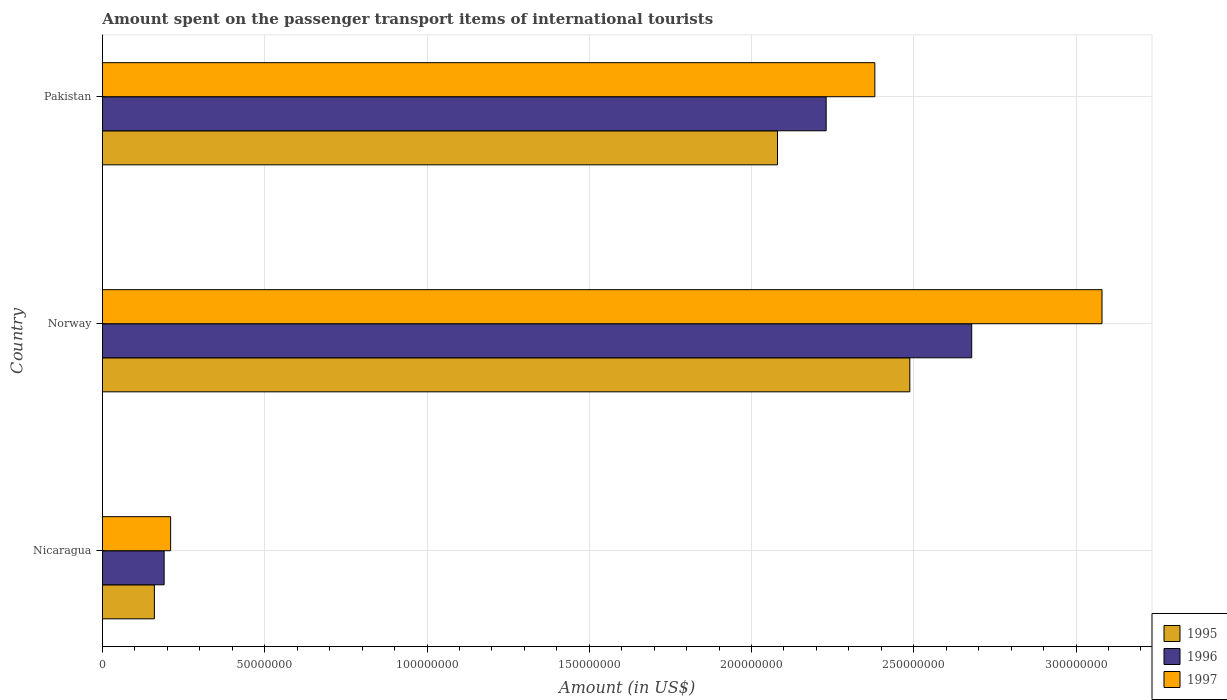What is the amount spent on the passenger transport items of international tourists in 1997 in Norway?
Ensure brevity in your answer.  3.08e+08. Across all countries, what is the maximum amount spent on the passenger transport items of international tourists in 1995?
Give a very brief answer. 2.49e+08. Across all countries, what is the minimum amount spent on the passenger transport items of international tourists in 1995?
Offer a terse response. 1.60e+07. In which country was the amount spent on the passenger transport items of international tourists in 1995 maximum?
Your response must be concise. Norway. In which country was the amount spent on the passenger transport items of international tourists in 1997 minimum?
Make the answer very short. Nicaragua. What is the total amount spent on the passenger transport items of international tourists in 1997 in the graph?
Your response must be concise. 5.67e+08. What is the difference between the amount spent on the passenger transport items of international tourists in 1996 in Nicaragua and that in Norway?
Make the answer very short. -2.49e+08. What is the difference between the amount spent on the passenger transport items of international tourists in 1996 in Pakistan and the amount spent on the passenger transport items of international tourists in 1997 in Norway?
Your answer should be very brief. -8.50e+07. What is the average amount spent on the passenger transport items of international tourists in 1996 per country?
Your answer should be compact. 1.70e+08. What is the difference between the amount spent on the passenger transport items of international tourists in 1996 and amount spent on the passenger transport items of international tourists in 1997 in Pakistan?
Ensure brevity in your answer.  -1.50e+07. What is the ratio of the amount spent on the passenger transport items of international tourists in 1997 in Nicaragua to that in Norway?
Provide a short and direct response. 0.07. What is the difference between the highest and the second highest amount spent on the passenger transport items of international tourists in 1997?
Offer a very short reply. 7.00e+07. What is the difference between the highest and the lowest amount spent on the passenger transport items of international tourists in 1996?
Ensure brevity in your answer.  2.49e+08. In how many countries, is the amount spent on the passenger transport items of international tourists in 1996 greater than the average amount spent on the passenger transport items of international tourists in 1996 taken over all countries?
Offer a terse response. 2. Is the sum of the amount spent on the passenger transport items of international tourists in 1997 in Nicaragua and Norway greater than the maximum amount spent on the passenger transport items of international tourists in 1995 across all countries?
Your response must be concise. Yes. How many bars are there?
Your answer should be compact. 9. What is the difference between two consecutive major ticks on the X-axis?
Offer a very short reply. 5.00e+07. Are the values on the major ticks of X-axis written in scientific E-notation?
Make the answer very short. No. Does the graph contain any zero values?
Offer a terse response. No. What is the title of the graph?
Your answer should be compact. Amount spent on the passenger transport items of international tourists. Does "1983" appear as one of the legend labels in the graph?
Make the answer very short. No. What is the label or title of the Y-axis?
Give a very brief answer. Country. What is the Amount (in US$) of 1995 in Nicaragua?
Offer a terse response. 1.60e+07. What is the Amount (in US$) in 1996 in Nicaragua?
Offer a terse response. 1.90e+07. What is the Amount (in US$) of 1997 in Nicaragua?
Provide a short and direct response. 2.10e+07. What is the Amount (in US$) of 1995 in Norway?
Offer a terse response. 2.49e+08. What is the Amount (in US$) of 1996 in Norway?
Provide a succinct answer. 2.68e+08. What is the Amount (in US$) in 1997 in Norway?
Provide a succinct answer. 3.08e+08. What is the Amount (in US$) of 1995 in Pakistan?
Your answer should be compact. 2.08e+08. What is the Amount (in US$) in 1996 in Pakistan?
Offer a terse response. 2.23e+08. What is the Amount (in US$) of 1997 in Pakistan?
Your answer should be very brief. 2.38e+08. Across all countries, what is the maximum Amount (in US$) in 1995?
Offer a very short reply. 2.49e+08. Across all countries, what is the maximum Amount (in US$) of 1996?
Your answer should be very brief. 2.68e+08. Across all countries, what is the maximum Amount (in US$) in 1997?
Offer a terse response. 3.08e+08. Across all countries, what is the minimum Amount (in US$) of 1995?
Your response must be concise. 1.60e+07. Across all countries, what is the minimum Amount (in US$) of 1996?
Provide a succinct answer. 1.90e+07. Across all countries, what is the minimum Amount (in US$) in 1997?
Keep it short and to the point. 2.10e+07. What is the total Amount (in US$) in 1995 in the graph?
Make the answer very short. 4.73e+08. What is the total Amount (in US$) in 1996 in the graph?
Keep it short and to the point. 5.10e+08. What is the total Amount (in US$) in 1997 in the graph?
Offer a terse response. 5.67e+08. What is the difference between the Amount (in US$) in 1995 in Nicaragua and that in Norway?
Give a very brief answer. -2.33e+08. What is the difference between the Amount (in US$) in 1996 in Nicaragua and that in Norway?
Provide a succinct answer. -2.49e+08. What is the difference between the Amount (in US$) in 1997 in Nicaragua and that in Norway?
Provide a short and direct response. -2.87e+08. What is the difference between the Amount (in US$) in 1995 in Nicaragua and that in Pakistan?
Your answer should be compact. -1.92e+08. What is the difference between the Amount (in US$) of 1996 in Nicaragua and that in Pakistan?
Provide a succinct answer. -2.04e+08. What is the difference between the Amount (in US$) of 1997 in Nicaragua and that in Pakistan?
Your response must be concise. -2.17e+08. What is the difference between the Amount (in US$) in 1995 in Norway and that in Pakistan?
Offer a terse response. 4.08e+07. What is the difference between the Amount (in US$) of 1996 in Norway and that in Pakistan?
Your response must be concise. 4.48e+07. What is the difference between the Amount (in US$) in 1997 in Norway and that in Pakistan?
Your answer should be very brief. 7.00e+07. What is the difference between the Amount (in US$) in 1995 in Nicaragua and the Amount (in US$) in 1996 in Norway?
Keep it short and to the point. -2.52e+08. What is the difference between the Amount (in US$) in 1995 in Nicaragua and the Amount (in US$) in 1997 in Norway?
Your answer should be very brief. -2.92e+08. What is the difference between the Amount (in US$) of 1996 in Nicaragua and the Amount (in US$) of 1997 in Norway?
Provide a succinct answer. -2.89e+08. What is the difference between the Amount (in US$) in 1995 in Nicaragua and the Amount (in US$) in 1996 in Pakistan?
Your answer should be compact. -2.07e+08. What is the difference between the Amount (in US$) in 1995 in Nicaragua and the Amount (in US$) in 1997 in Pakistan?
Make the answer very short. -2.22e+08. What is the difference between the Amount (in US$) of 1996 in Nicaragua and the Amount (in US$) of 1997 in Pakistan?
Keep it short and to the point. -2.19e+08. What is the difference between the Amount (in US$) in 1995 in Norway and the Amount (in US$) in 1996 in Pakistan?
Provide a succinct answer. 2.58e+07. What is the difference between the Amount (in US$) of 1995 in Norway and the Amount (in US$) of 1997 in Pakistan?
Your response must be concise. 1.08e+07. What is the difference between the Amount (in US$) of 1996 in Norway and the Amount (in US$) of 1997 in Pakistan?
Offer a very short reply. 2.98e+07. What is the average Amount (in US$) in 1995 per country?
Ensure brevity in your answer.  1.58e+08. What is the average Amount (in US$) of 1996 per country?
Your answer should be very brief. 1.70e+08. What is the average Amount (in US$) of 1997 per country?
Give a very brief answer. 1.89e+08. What is the difference between the Amount (in US$) of 1995 and Amount (in US$) of 1997 in Nicaragua?
Give a very brief answer. -5.00e+06. What is the difference between the Amount (in US$) of 1996 and Amount (in US$) of 1997 in Nicaragua?
Make the answer very short. -2.00e+06. What is the difference between the Amount (in US$) in 1995 and Amount (in US$) in 1996 in Norway?
Give a very brief answer. -1.91e+07. What is the difference between the Amount (in US$) of 1995 and Amount (in US$) of 1997 in Norway?
Ensure brevity in your answer.  -5.92e+07. What is the difference between the Amount (in US$) in 1996 and Amount (in US$) in 1997 in Norway?
Make the answer very short. -4.02e+07. What is the difference between the Amount (in US$) of 1995 and Amount (in US$) of 1996 in Pakistan?
Ensure brevity in your answer.  -1.50e+07. What is the difference between the Amount (in US$) of 1995 and Amount (in US$) of 1997 in Pakistan?
Your response must be concise. -3.00e+07. What is the difference between the Amount (in US$) of 1996 and Amount (in US$) of 1997 in Pakistan?
Provide a short and direct response. -1.50e+07. What is the ratio of the Amount (in US$) of 1995 in Nicaragua to that in Norway?
Make the answer very short. 0.06. What is the ratio of the Amount (in US$) in 1996 in Nicaragua to that in Norway?
Provide a succinct answer. 0.07. What is the ratio of the Amount (in US$) of 1997 in Nicaragua to that in Norway?
Make the answer very short. 0.07. What is the ratio of the Amount (in US$) of 1995 in Nicaragua to that in Pakistan?
Offer a terse response. 0.08. What is the ratio of the Amount (in US$) of 1996 in Nicaragua to that in Pakistan?
Your answer should be very brief. 0.09. What is the ratio of the Amount (in US$) in 1997 in Nicaragua to that in Pakistan?
Give a very brief answer. 0.09. What is the ratio of the Amount (in US$) of 1995 in Norway to that in Pakistan?
Give a very brief answer. 1.2. What is the ratio of the Amount (in US$) in 1996 in Norway to that in Pakistan?
Offer a terse response. 1.2. What is the ratio of the Amount (in US$) of 1997 in Norway to that in Pakistan?
Keep it short and to the point. 1.29. What is the difference between the highest and the second highest Amount (in US$) in 1995?
Give a very brief answer. 4.08e+07. What is the difference between the highest and the second highest Amount (in US$) in 1996?
Your answer should be very brief. 4.48e+07. What is the difference between the highest and the second highest Amount (in US$) in 1997?
Offer a terse response. 7.00e+07. What is the difference between the highest and the lowest Amount (in US$) of 1995?
Provide a succinct answer. 2.33e+08. What is the difference between the highest and the lowest Amount (in US$) of 1996?
Provide a short and direct response. 2.49e+08. What is the difference between the highest and the lowest Amount (in US$) of 1997?
Keep it short and to the point. 2.87e+08. 